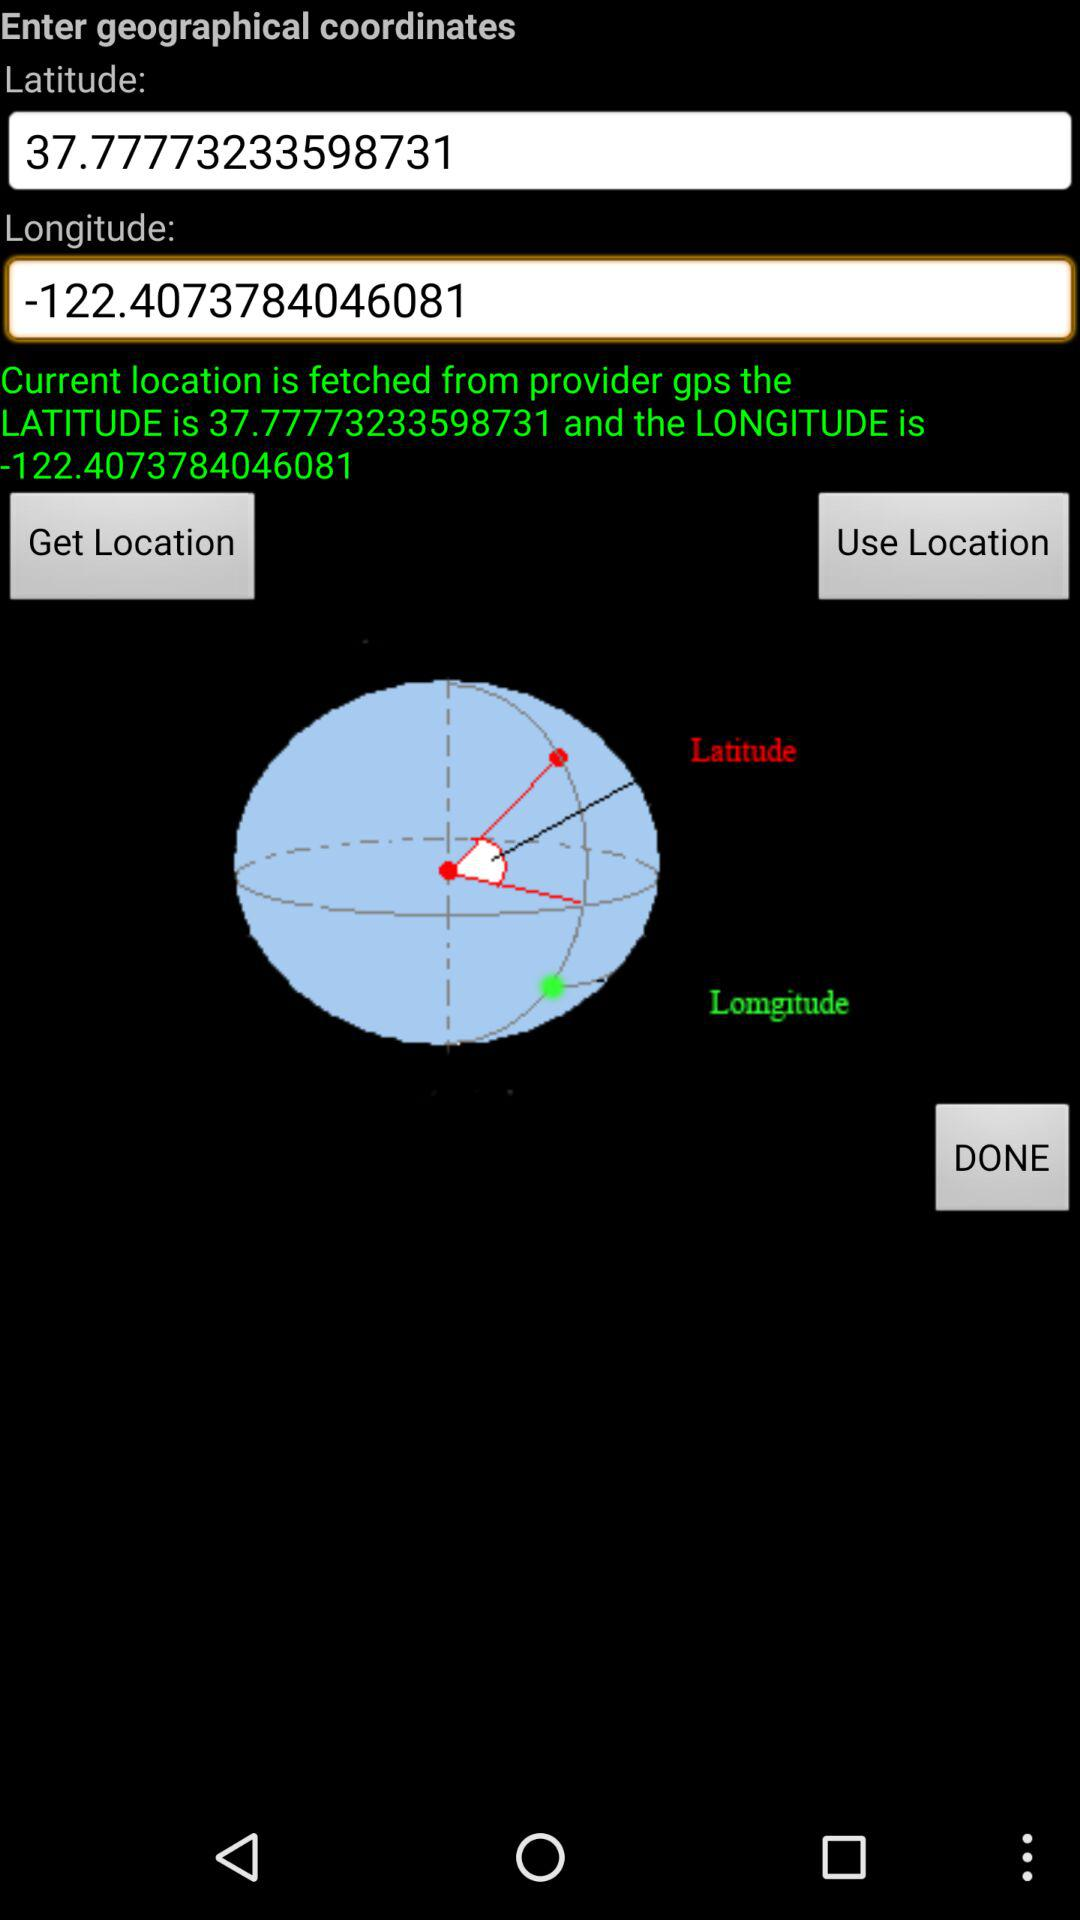What is the degree of the angle?
When the provided information is insufficient, respond with <no answer>. <no answer> 